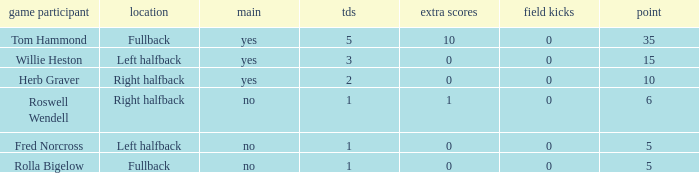What is the lowest number of touchdowns for left halfback WIllie Heston who has more than 15 points? None. 